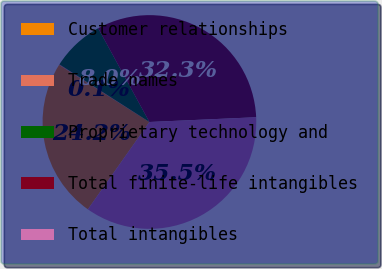Convert chart to OTSL. <chart><loc_0><loc_0><loc_500><loc_500><pie_chart><fcel>Customer relationships<fcel>Trade names<fcel>Proprietary technology and<fcel>Total finite-life intangibles<fcel>Total intangibles<nl><fcel>24.21%<fcel>0.09%<fcel>7.97%<fcel>32.26%<fcel>35.48%<nl></chart> 